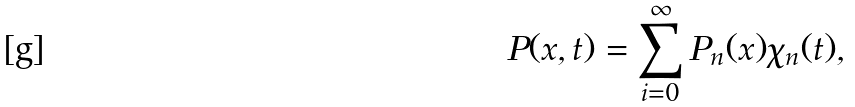<formula> <loc_0><loc_0><loc_500><loc_500>P ( { x } , t ) = \sum _ { i = 0 } ^ { \infty } P _ { n } ( { x } ) \chi _ { n } ( t ) ,</formula> 